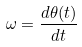<formula> <loc_0><loc_0><loc_500><loc_500>\omega = \frac { d \theta ( t ) } { d t }</formula> 